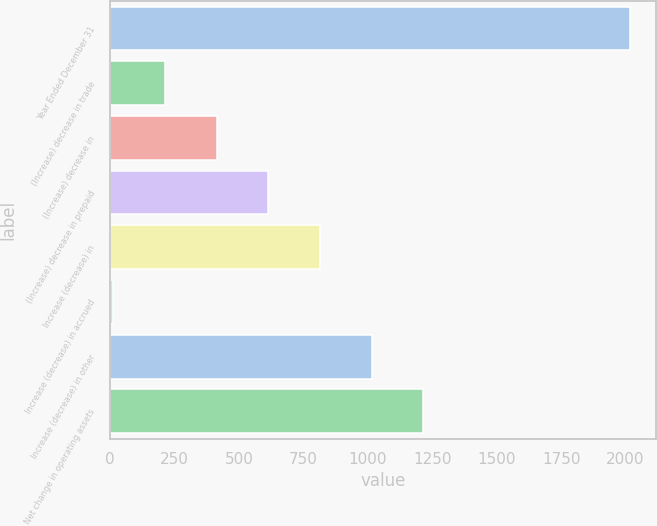Convert chart to OTSL. <chart><loc_0><loc_0><loc_500><loc_500><bar_chart><fcel>Year Ended December 31<fcel>(Increase) decrease in trade<fcel>(Increase) decrease in<fcel>(Increase) decrease in prepaid<fcel>Increase (decrease) in<fcel>Increase (decrease) in accrued<fcel>Increase (decrease) in other<fcel>Net change in operating assets<nl><fcel>2018<fcel>212.6<fcel>413.2<fcel>613.8<fcel>814.4<fcel>12<fcel>1015<fcel>1215.6<nl></chart> 